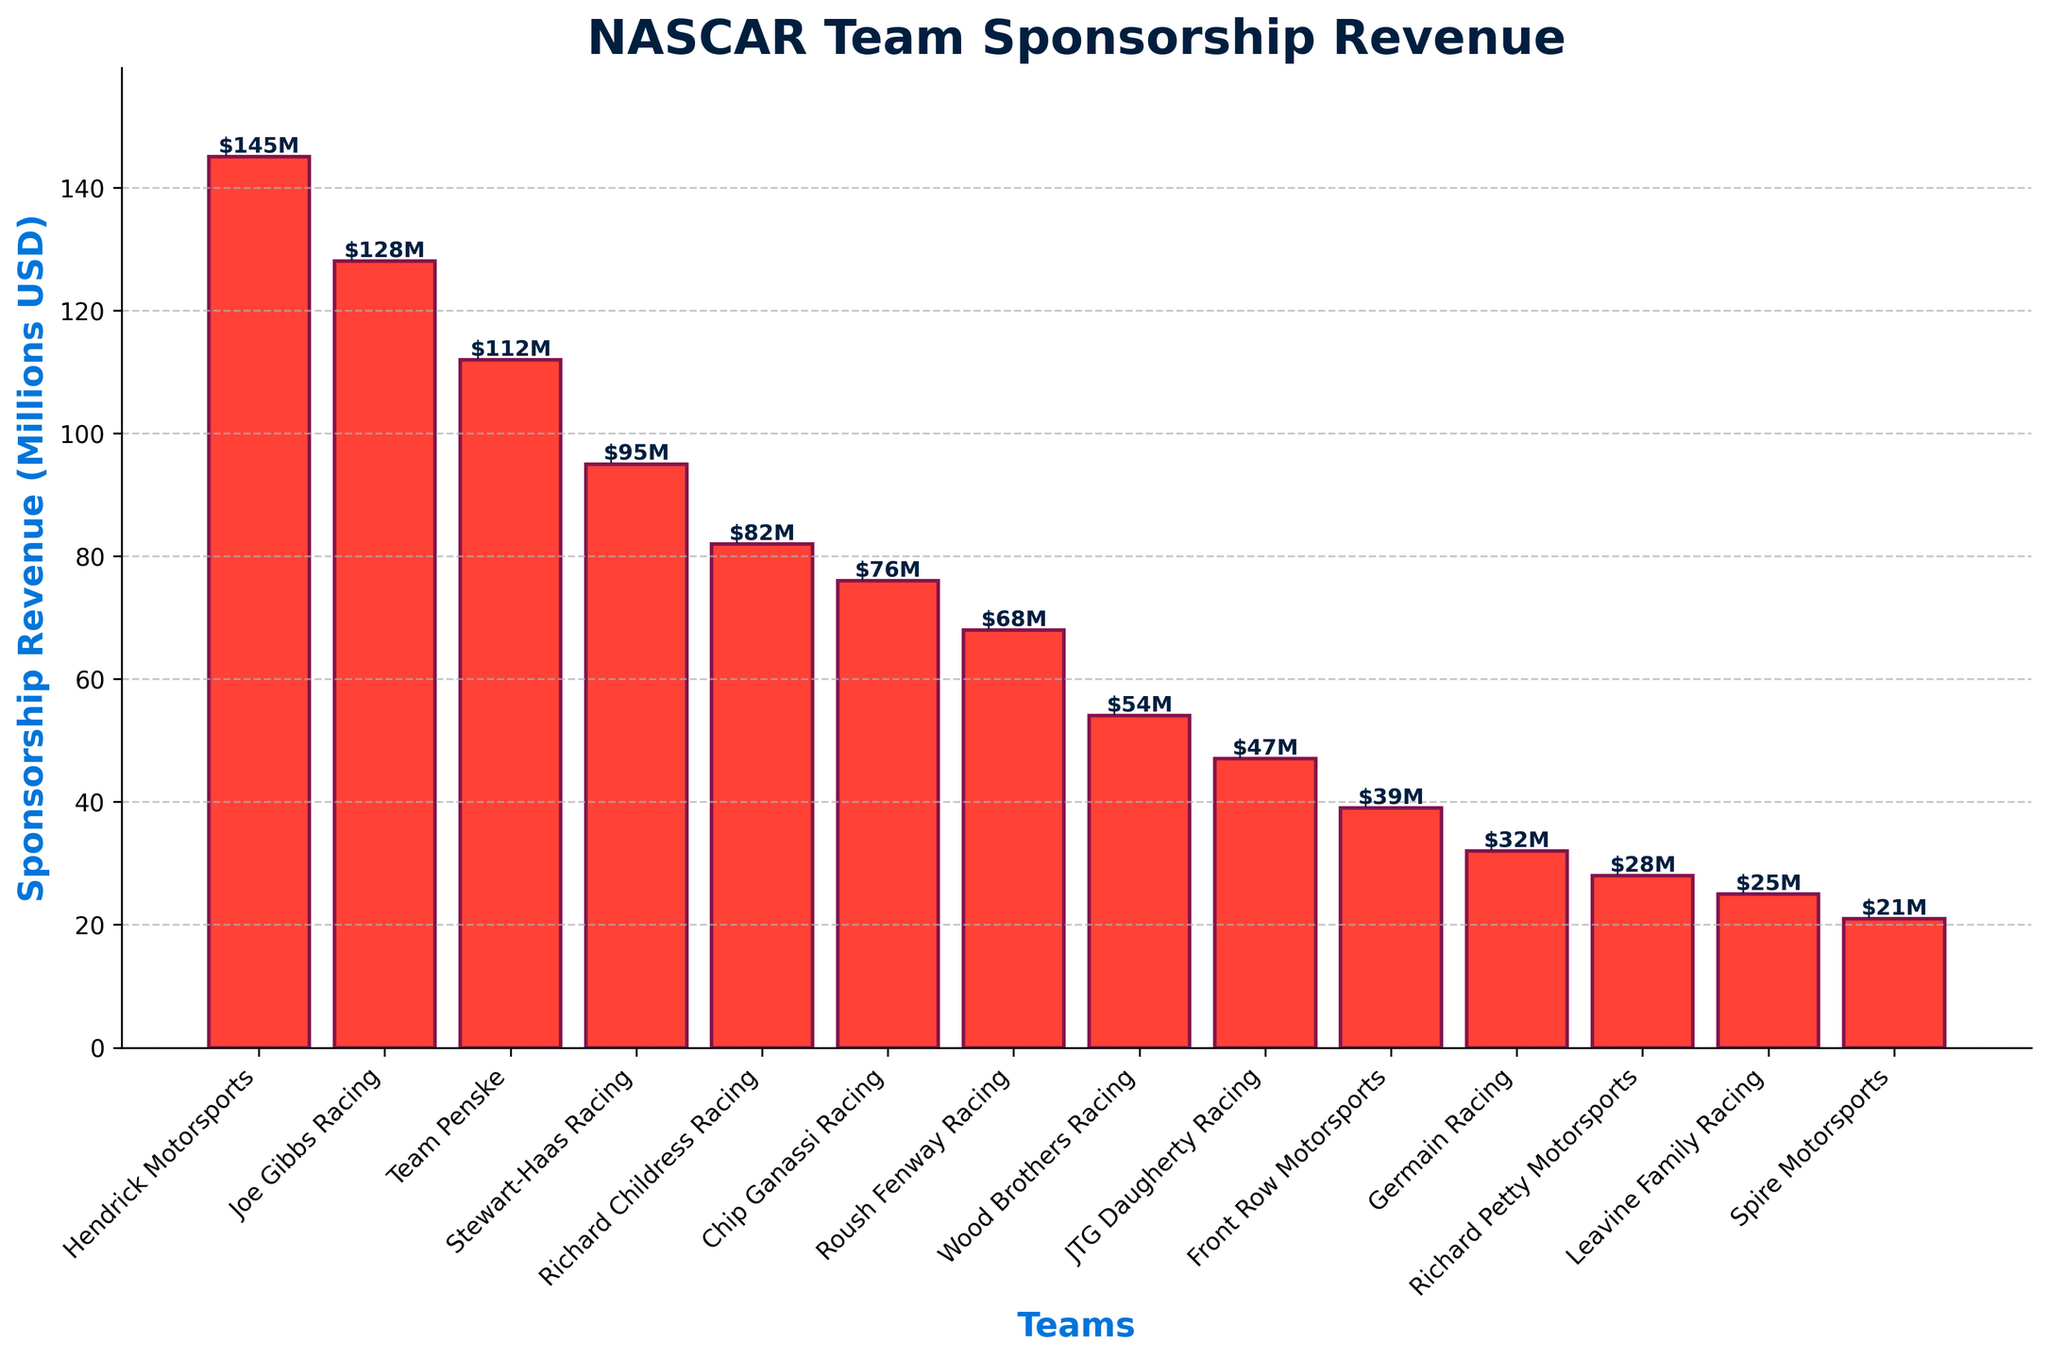Which team has the highest sponsorship revenue? Hendrick Motorsports' bar is the tallest, indicating it has the highest sponsorship revenue among the NASCAR teams.
Answer: Hendrick Motorsports Which team has the lowest sponsorship revenue? Spire Motorsports' bar is the shortest, indicating it has the lowest sponsorship revenue among the NASCAR teams.
Answer: Spire Motorsports What is the sum of the sponsorship revenues of Stewart-Haas Racing and Richard Childress Racing? The revenue for Stewart-Haas Racing is 95 million USD, and for Richard Childress Racing is 82 million USD. Adding these together: 95 + 82 = 177.
Answer: 177 million USD Is Joe Gibbs Racing's sponsorship revenue greater than Team Penske's? Joe Gibbs Racing's bar is taller than Team Penske's, indicating Joe Gibbs Racing's revenue (128 million USD) is greater than Team Penske's (112 million USD).
Answer: Yes Which two teams have sponsorship revenues close to each other? Richard Childress Racing and Chip Ganassi Racing have closely aligned bars, indicating their revenues are 82 million USD and 76 million USD, respectively.
Answer: Richard Childress Racing and Chip Ganassi Racing What is the difference in sponsorship revenue between Joe Gibbs Racing and Stewart-Haas Racing? The revenue for Joe Gibbs Racing is 128 million USD, and for Stewart-Haas Racing is 95 million USD. The difference is: 128 - 95 = 33.
Answer: 33 million USD Which team has a sponsorship revenue closest to 50 million USD? Wood Brothers Racing's bar reaches 54 million USD, which is the closest to 50 million USD among the teams.
Answer: Wood Brothers Racing What is the average sponsorship revenue of the top 3 teams? The revenues of the top 3 teams are: Hendrick Motorsports (145 million USD), Joe Gibbs Racing (128 million USD), and Team Penske (112 million USD). The sum is 145 + 128 + 112 = 385. The average is 385 / 3 ≈ 128.33.
Answer: 128.33 million USD Which team shows a sponsorship revenue of 25 million USD? The bar corresponding to Leavine Family Racing reaches 25 million USD.
Answer: Leavine Family Racing What is the total sponsorship revenue for the bottom 5 teams? The revenues for the bottom 5 teams are: Front Row Motorsports (39 million USD), Germain Racing (32 million USD), Richard Petty Motorsports (28 million USD), Leavine Family Racing (25 million USD), and Spire Motorsports (21 million USD). The sum is 39 + 32 + 28 + 25 + 21 = 145.
Answer: 145 million USD 